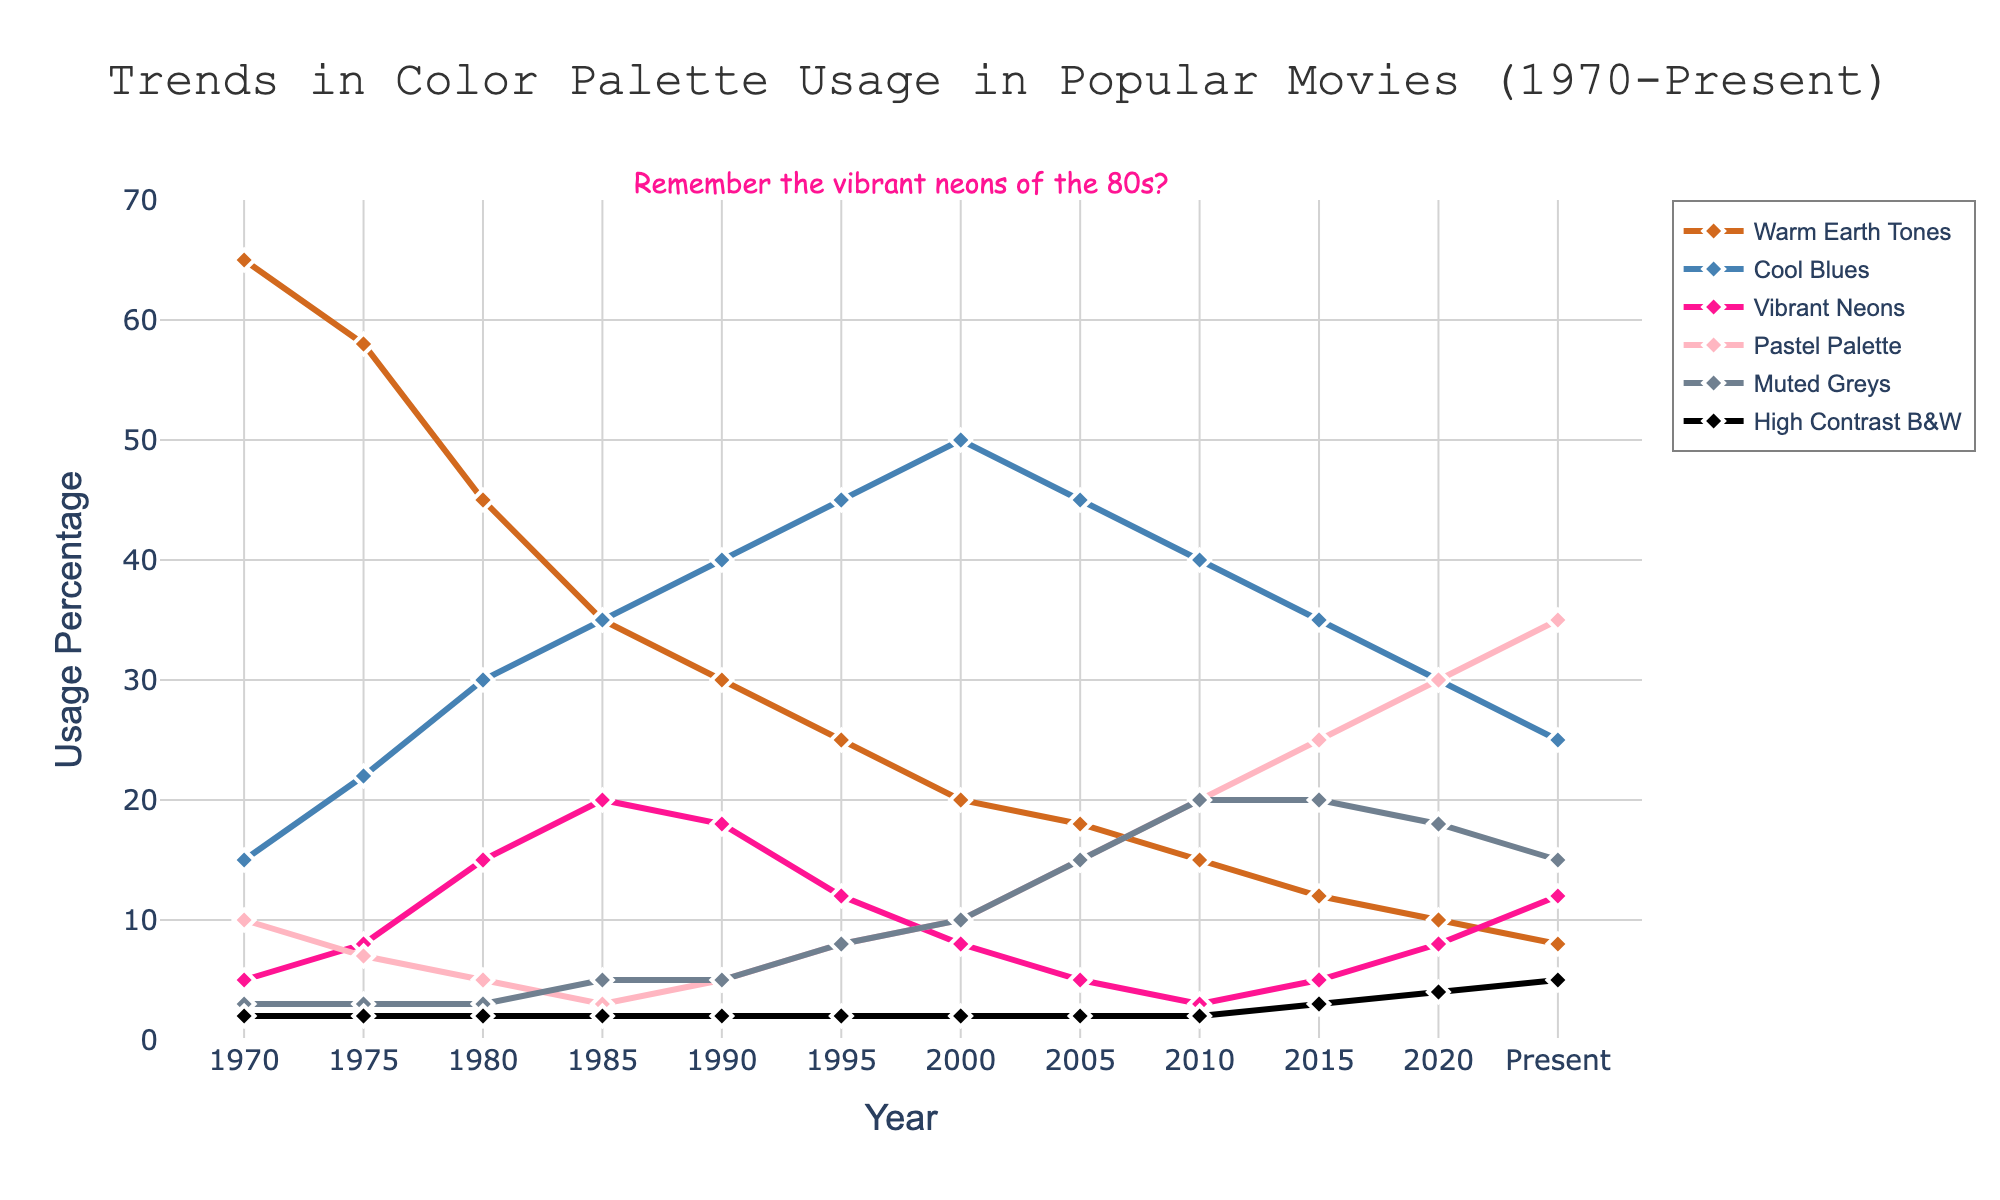When did the Warm Earth Tones usage reach its peak, and what was the percentage? Look at the data points of the Warm Earth Tones series (represented by a specific color in the plot) and identify the highest value. The peak usage was in 1970 with a percentage of 65%.
Answer: 1970, 65% Which color palette shows a consistent increase in usage from 1970 to Present? Examine the trend lines for all the color palettes and identify the one that shows a steady increase over the years. The Pastel Palette has shown a consistent increase from 1970 to Present.
Answer: Pastel Palette In what year did Cool Blues surpass Warm Earth Tones in usage? Compare the usage percentages of Cool Blues and Warm Earth Tones over the years and identify the year where Cool Blues' usage first becomes higher than that of Warm Earth Tones. This occurred in 1980.
Answer: 1980 What is the approximate average usage of Muted Greys from 2005 to Present? Calculate the average of the Muted Greys data points from 2005 to Present by summing up the numbers and dividing by the number of years. The values are (15+20+20+18+15)=88 over 5 years, so 88/5 = 17.6.
Answer: 17.6 Which two color palettes had the same usage percentage in 1970 and what was that percentage? Identify the color palettes that intersect or have the same value in 1970 by looking at the points for that year. Both Muted Greys and High Contrast B&W had a usage of 2% in 1970.
Answer: Muted Greys, High Contrast B&W; 2% During which decade did Vibrant Neons see the most significant increase in usage? Determine the decade with the highest slope in the usage trend for Vibrant Neons. The most significant increase occurred in the 1980s.
Answer: 1980s What is the overall trend of Warm Earth Tones from 1970 to Present? Evaluate the general direction of the Warm Earth Tones line from the start to the end, considering any rises and falls. The overall trend shows a gradual decline from 1970 to Present.
Answer: Gradual decline How does the usage of High Contrast B&W in 2020 compare to its usage in 1970? Compare the two specific data points for High Contrast B&W in the years 2020 and 1970. In 2020, it was 4%, which is higher than the 2% usage in 1970.
Answer: Higher Which year marks the highest difference in percentage between Warm Earth Tones and Cool Blues? Calculate the difference between Warm Earth Tones and Cool Blues for each year and identify the maximum value. The year with the highest difference is 1970, where the difference is 65 - 15 = 50%.
Answer: 1970, 50% What is the trend in the usage of Pastel Palette from 2000 to Present? Observe the line plotted for Pastel Palette from 2000 onwards and describe its direction. The trend shows a steady increase from 2000 to Present.
Answer: Steady increase 